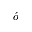Convert formula to latex. <formula><loc_0><loc_0><loc_500><loc_500>\acute { o }</formula> 